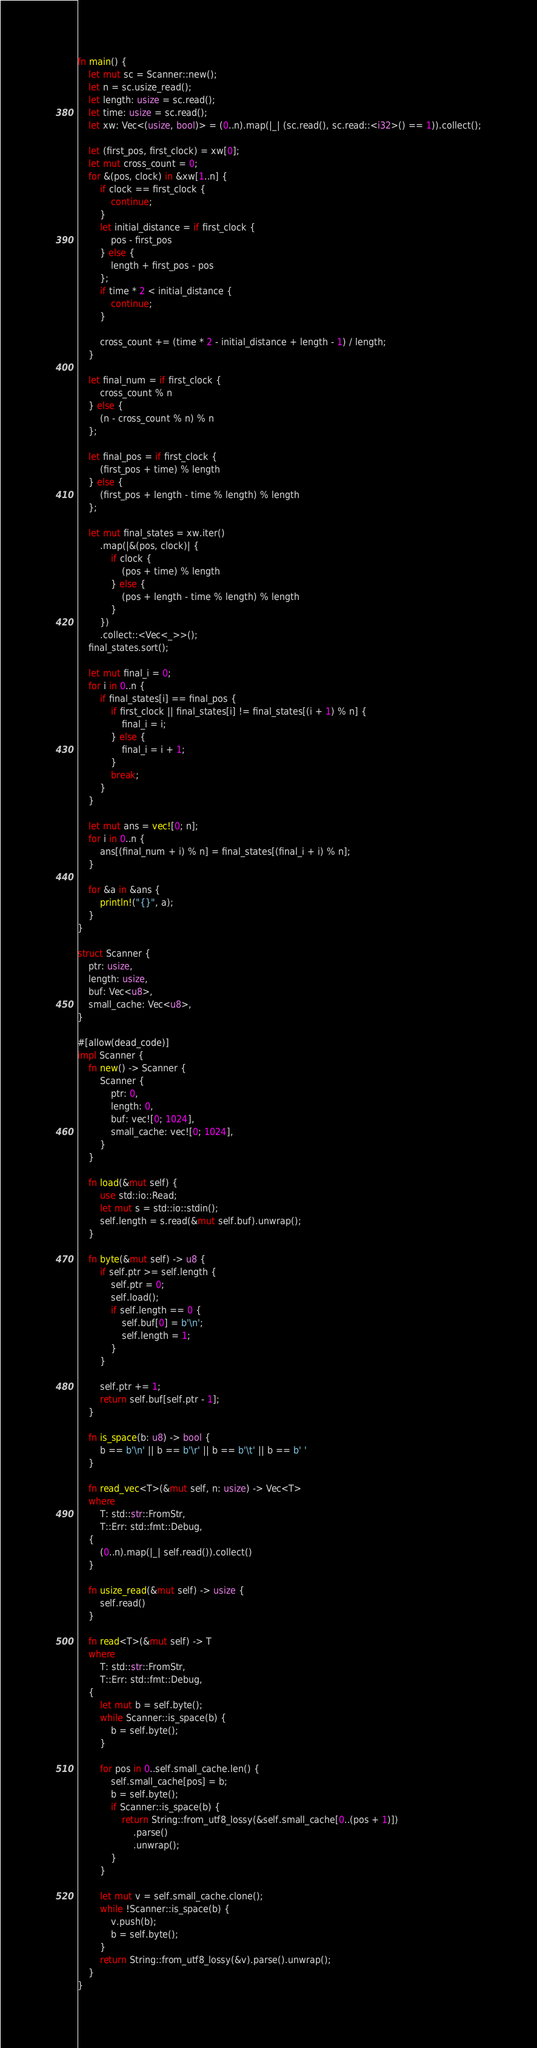<code> <loc_0><loc_0><loc_500><loc_500><_Rust_>fn main() {
    let mut sc = Scanner::new();
    let n = sc.usize_read();
    let length: usize = sc.read();
    let time: usize = sc.read();
    let xw: Vec<(usize, bool)> = (0..n).map(|_| (sc.read(), sc.read::<i32>() == 1)).collect();

    let (first_pos, first_clock) = xw[0];
    let mut cross_count = 0;
    for &(pos, clock) in &xw[1..n] {
        if clock == first_clock {
            continue;
        }
        let initial_distance = if first_clock {
            pos - first_pos
        } else {
            length + first_pos - pos
        };
        if time * 2 < initial_distance {
            continue;
        }

        cross_count += (time * 2 - initial_distance + length - 1) / length;
    }

    let final_num = if first_clock {
        cross_count % n
    } else {
        (n - cross_count % n) % n
    };

    let final_pos = if first_clock {
        (first_pos + time) % length
    } else {
        (first_pos + length - time % length) % length
    };

    let mut final_states = xw.iter()
        .map(|&(pos, clock)| {
            if clock {
                (pos + time) % length
            } else {
                (pos + length - time % length) % length
            }
        })
        .collect::<Vec<_>>();
    final_states.sort();

    let mut final_i = 0;
    for i in 0..n {
        if final_states[i] == final_pos {
            if first_clock || final_states[i] != final_states[(i + 1) % n] {
                final_i = i;
            } else {
                final_i = i + 1;
            }
            break;
        }
    }

    let mut ans = vec![0; n];
    for i in 0..n {
        ans[(final_num + i) % n] = final_states[(final_i + i) % n];
    }

    for &a in &ans {
        println!("{}", a);
    }
}

struct Scanner {
    ptr: usize,
    length: usize,
    buf: Vec<u8>,
    small_cache: Vec<u8>,
}

#[allow(dead_code)]
impl Scanner {
    fn new() -> Scanner {
        Scanner {
            ptr: 0,
            length: 0,
            buf: vec![0; 1024],
            small_cache: vec![0; 1024],
        }
    }

    fn load(&mut self) {
        use std::io::Read;
        let mut s = std::io::stdin();
        self.length = s.read(&mut self.buf).unwrap();
    }

    fn byte(&mut self) -> u8 {
        if self.ptr >= self.length {
            self.ptr = 0;
            self.load();
            if self.length == 0 {
                self.buf[0] = b'\n';
                self.length = 1;
            }
        }

        self.ptr += 1;
        return self.buf[self.ptr - 1];
    }

    fn is_space(b: u8) -> bool {
        b == b'\n' || b == b'\r' || b == b'\t' || b == b' '
    }

    fn read_vec<T>(&mut self, n: usize) -> Vec<T>
    where
        T: std::str::FromStr,
        T::Err: std::fmt::Debug,
    {
        (0..n).map(|_| self.read()).collect()
    }

    fn usize_read(&mut self) -> usize {
        self.read()
    }

    fn read<T>(&mut self) -> T
    where
        T: std::str::FromStr,
        T::Err: std::fmt::Debug,
    {
        let mut b = self.byte();
        while Scanner::is_space(b) {
            b = self.byte();
        }

        for pos in 0..self.small_cache.len() {
            self.small_cache[pos] = b;
            b = self.byte();
            if Scanner::is_space(b) {
                return String::from_utf8_lossy(&self.small_cache[0..(pos + 1)])
                    .parse()
                    .unwrap();
            }
        }

        let mut v = self.small_cache.clone();
        while !Scanner::is_space(b) {
            v.push(b);
            b = self.byte();
        }
        return String::from_utf8_lossy(&v).parse().unwrap();
    }
}
</code> 